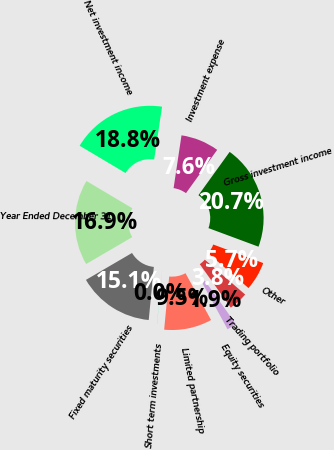Convert chart. <chart><loc_0><loc_0><loc_500><loc_500><pie_chart><fcel>Year Ended December 31<fcel>Fixed maturity securities<fcel>Short term investments<fcel>Limited partnership<fcel>Equity securities<fcel>Trading portfolio<fcel>Other<fcel>Gross investment income<fcel>Investment expense<fcel>Net investment income<nl><fcel>16.95%<fcel>15.06%<fcel>0.02%<fcel>9.46%<fcel>1.91%<fcel>3.8%<fcel>5.68%<fcel>20.72%<fcel>7.57%<fcel>18.83%<nl></chart> 